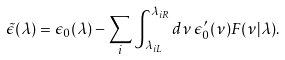<formula> <loc_0><loc_0><loc_500><loc_500>\tilde { \epsilon } ( \lambda ) = \epsilon _ { 0 } ( \lambda ) - \sum _ { i } \int _ { \lambda _ { i L } } ^ { \lambda _ { i R } } d \nu \, \epsilon _ { 0 } ^ { \prime } ( \nu ) F ( \nu | \lambda ) .</formula> 